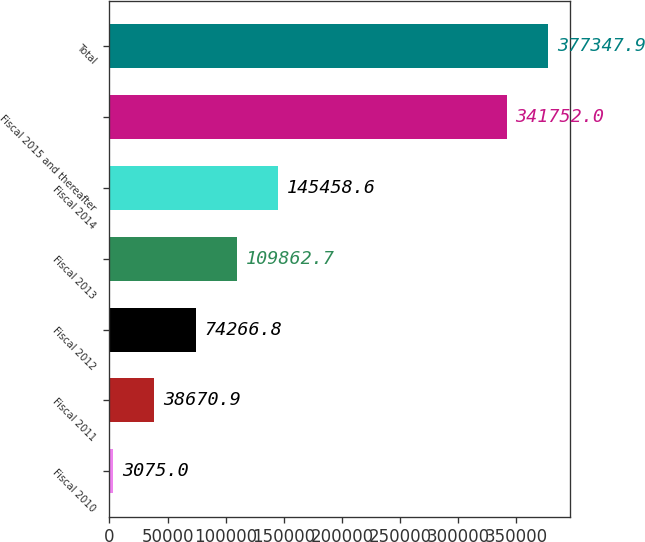<chart> <loc_0><loc_0><loc_500><loc_500><bar_chart><fcel>Fiscal 2010<fcel>Fiscal 2011<fcel>Fiscal 2012<fcel>Fiscal 2013<fcel>Fiscal 2014<fcel>Fiscal 2015 and thereafter<fcel>Total<nl><fcel>3075<fcel>38670.9<fcel>74266.8<fcel>109863<fcel>145459<fcel>341752<fcel>377348<nl></chart> 